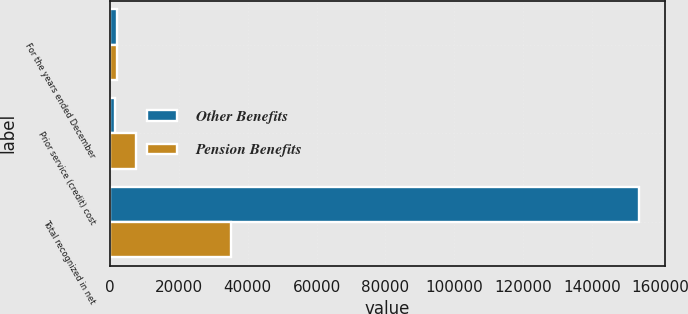Convert chart to OTSL. <chart><loc_0><loc_0><loc_500><loc_500><stacked_bar_chart><ecel><fcel>For the years ended December<fcel>Prior service (credit) cost<fcel>Total recognized in net<nl><fcel>Other Benefits<fcel>2011<fcel>1313<fcel>153605<nl><fcel>Pension Benefits<fcel>2011<fcel>7614<fcel>35048<nl></chart> 